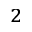Convert formula to latex. <formula><loc_0><loc_0><loc_500><loc_500>_ { 2 }</formula> 